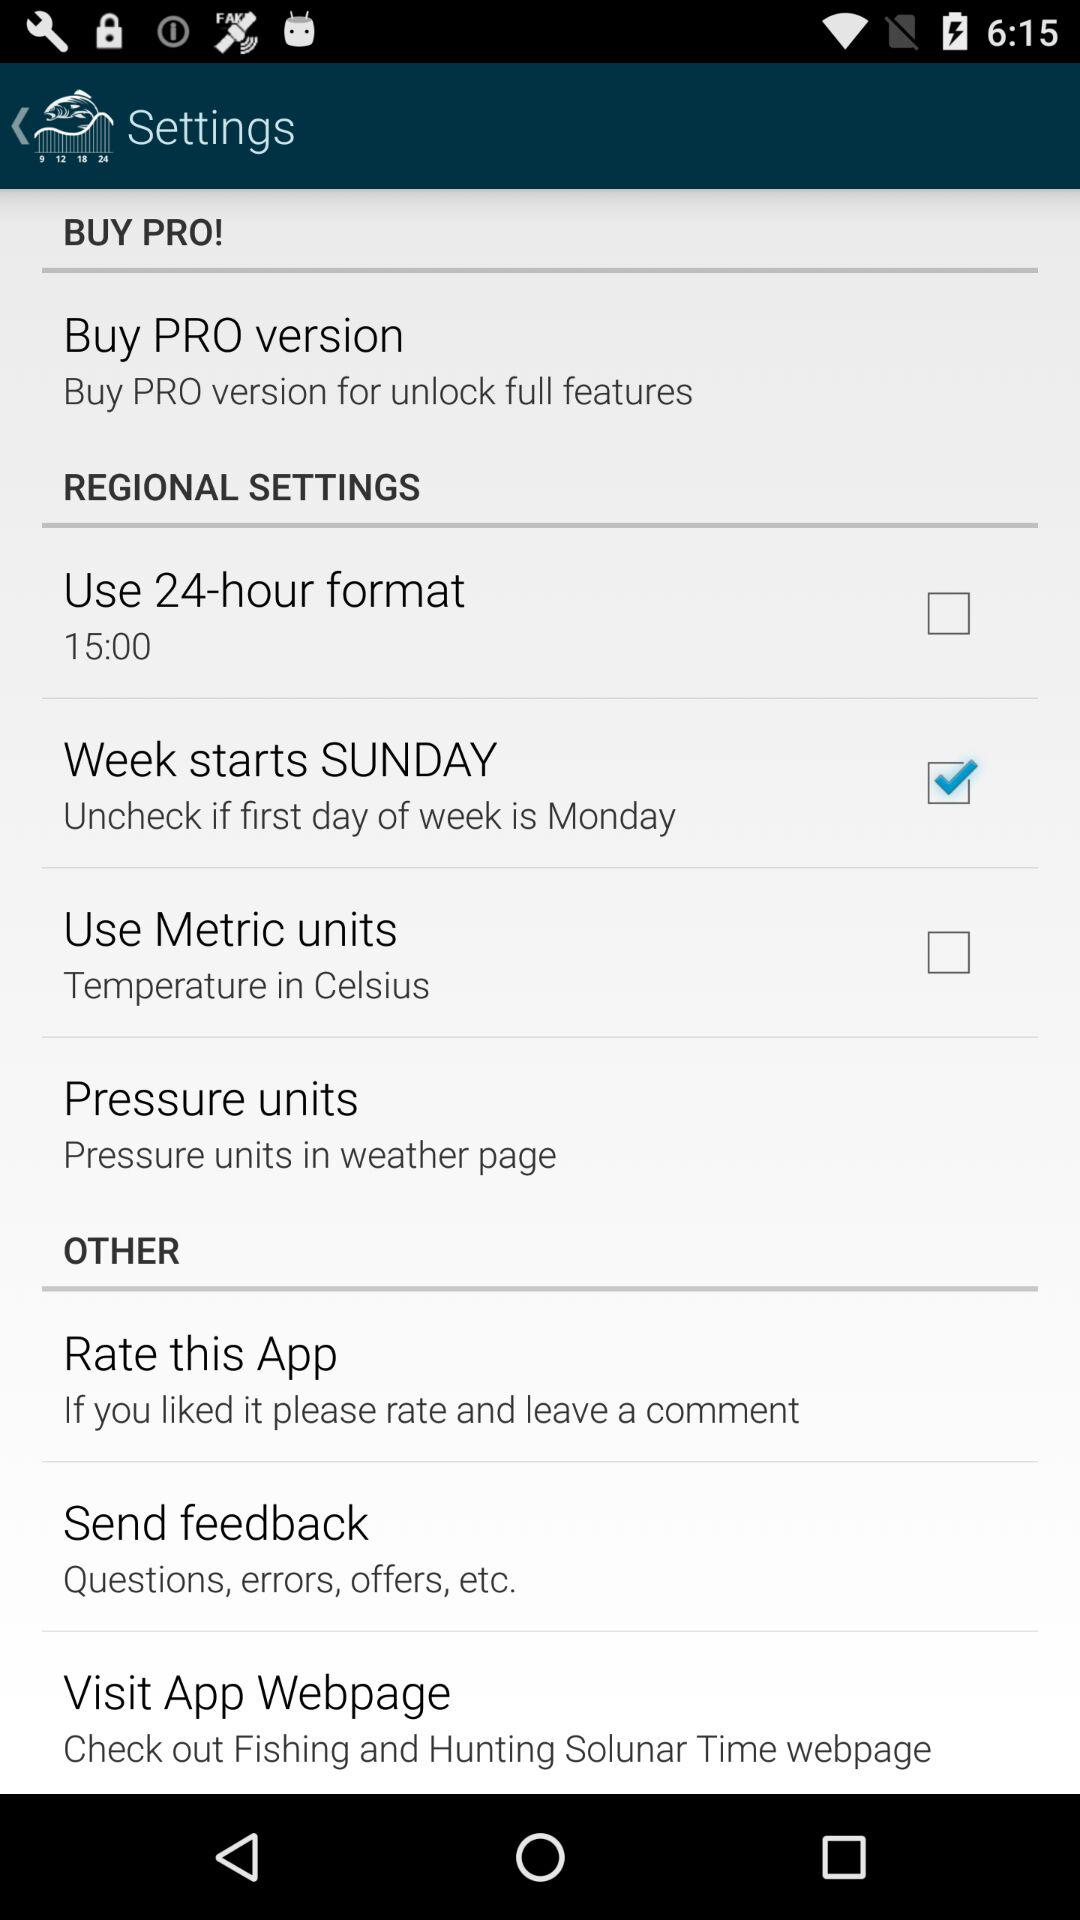What is the status of the "Use Metric units"? The status is "off". 